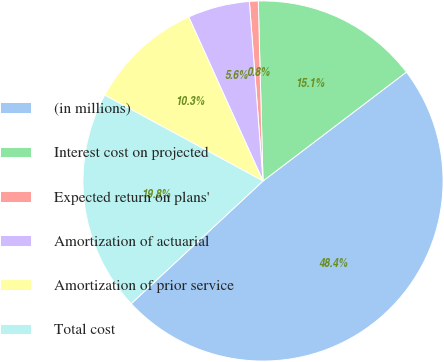Convert chart. <chart><loc_0><loc_0><loc_500><loc_500><pie_chart><fcel>(in millions)<fcel>Interest cost on projected<fcel>Expected return on plans'<fcel>Amortization of actuarial<fcel>Amortization of prior service<fcel>Total cost<nl><fcel>48.41%<fcel>15.08%<fcel>0.79%<fcel>5.56%<fcel>10.32%<fcel>19.84%<nl></chart> 